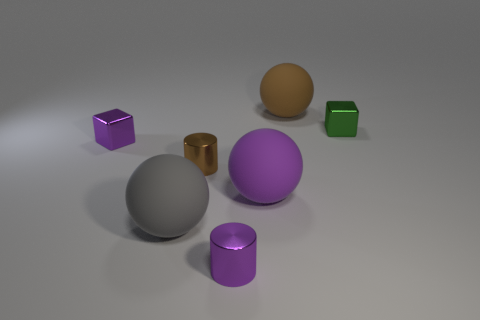Add 2 tiny cylinders. How many objects exist? 9 Subtract all balls. How many objects are left? 4 Subtract 0 cyan cubes. How many objects are left? 7 Subtract all large brown rubber spheres. Subtract all gray rubber things. How many objects are left? 5 Add 1 purple metallic cylinders. How many purple metallic cylinders are left? 2 Add 5 big cyan matte spheres. How many big cyan matte spheres exist? 5 